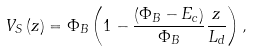Convert formula to latex. <formula><loc_0><loc_0><loc_500><loc_500>V _ { S } \left ( z \right ) = \Phi _ { B } \left ( 1 - \frac { \left ( \Phi _ { B } - E _ { c } \right ) } { \Phi _ { B } } \frac { z } { L _ { d } } \right ) ,</formula> 